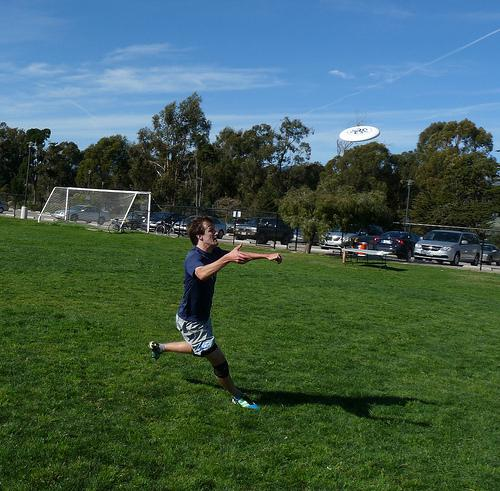Question: what is the person throwing?
Choices:
A. Football.
B. Baseball.
C. Basketball.
D. Frisbee.
Answer with the letter. Answer: D Question: where is the man?
Choices:
A. Yard.
B. Road.
C. Field.
D. Pond.
Answer with the letter. Answer: C Question: what color is the frisbee?
Choices:
A. Blue.
B. Yellow.
C. White.
D. Purple.
Answer with the letter. Answer: C 